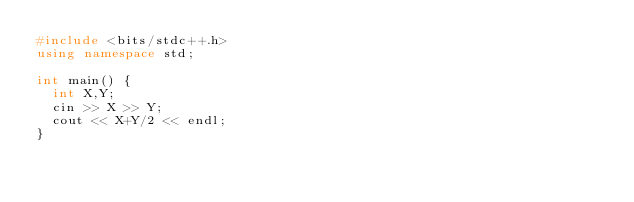<code> <loc_0><loc_0><loc_500><loc_500><_C++_>#include <bits/stdc++.h>
using namespace std;

int main() {
  int X,Y;
  cin >> X >> Y;
  cout << X+Y/2 << endl;
}
</code> 